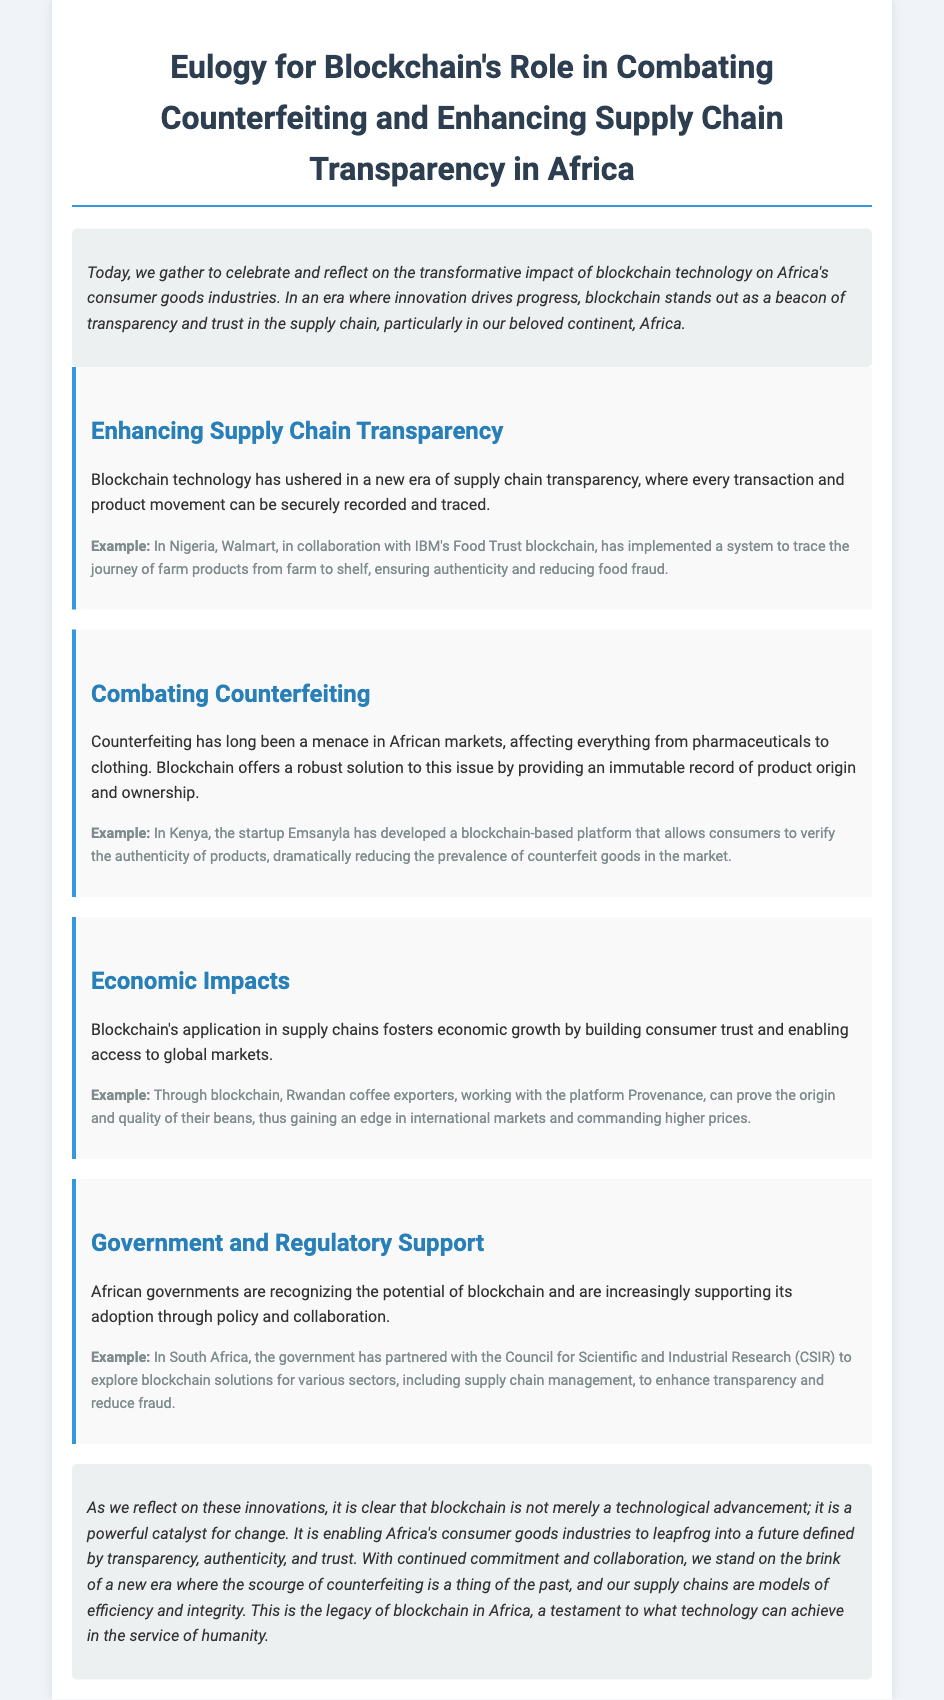what is the main technology discussed in the document? The document discusses the transformative impact of blockchain technology in Africa's consumer goods industries.
Answer: blockchain technology which country implemented a system to trace farm products using blockchain? The document mentions Nigeria as the country where Walmart and IBM's Food Trust blockchain has been implemented for tracing farm products.
Answer: Nigeria what product category is particularly affected by counterfeiting in Africa? The document states that counterfeiting affects various categories, particularly pharmaceuticals and clothing.
Answer: pharmaceuticals and clothing what platform did Emsanyla develop? Emsanyla developed a blockchain-based platform for verifying the authenticity of products.
Answer: blockchain-based platform how has blockchain affected Rwandan coffee exporters? The document explains that Rwandan coffee exporters using blockchain can prove the origin and quality of their beans, gaining an edge in international markets.
Answer: prove origin and quality which South African entity partnered with the government to explore blockchain solutions? The Council for Scientific and Industrial Research (CSIR) is the entity that partnered with the South African government to explore blockchain solutions.
Answer: CSIR what is the purpose of the blockchain technology in supply chains? The document states that the purpose is to enhance supply chain transparency and combat counterfeiting.
Answer: enhance transparency and combat counterfeiting how does the document describe the legacy of blockchain in Africa? The document describes the legacy of blockchain in Africa as a testament to achieving transparency, authenticity, and trust in consumer goods industries.
Answer: testament to achieving transparency, authenticity, and trust 